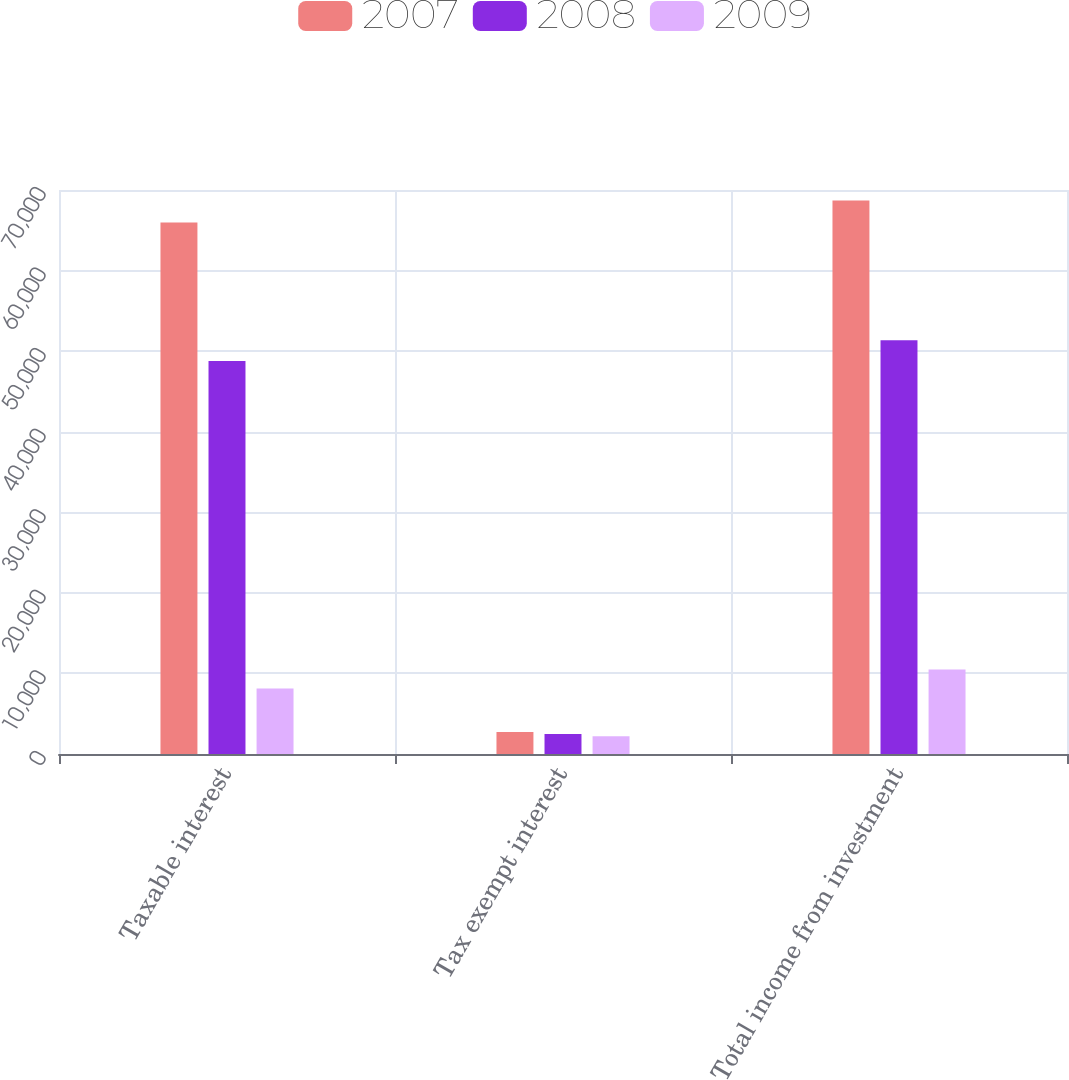<chart> <loc_0><loc_0><loc_500><loc_500><stacked_bar_chart><ecel><fcel>Taxable interest<fcel>Tax exempt interest<fcel>Total income from investment<nl><fcel>2007<fcel>65959<fcel>2735<fcel>68694<nl><fcel>2008<fcel>48787<fcel>2489<fcel>51345<nl><fcel>2009<fcel>8125<fcel>2197<fcel>10502<nl></chart> 